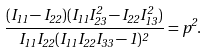<formula> <loc_0><loc_0><loc_500><loc_500>\frac { ( I _ { 1 1 } - I _ { 2 2 } ) ( I _ { 1 1 } I _ { 2 3 } ^ { 2 } - I _ { 2 2 } I _ { 1 3 } ^ { 2 } ) } { I _ { 1 1 } I _ { 2 2 } ( I _ { 1 1 } I _ { 2 2 } I _ { 3 3 } - 1 ) ^ { 2 } } = p ^ { 2 } .</formula> 